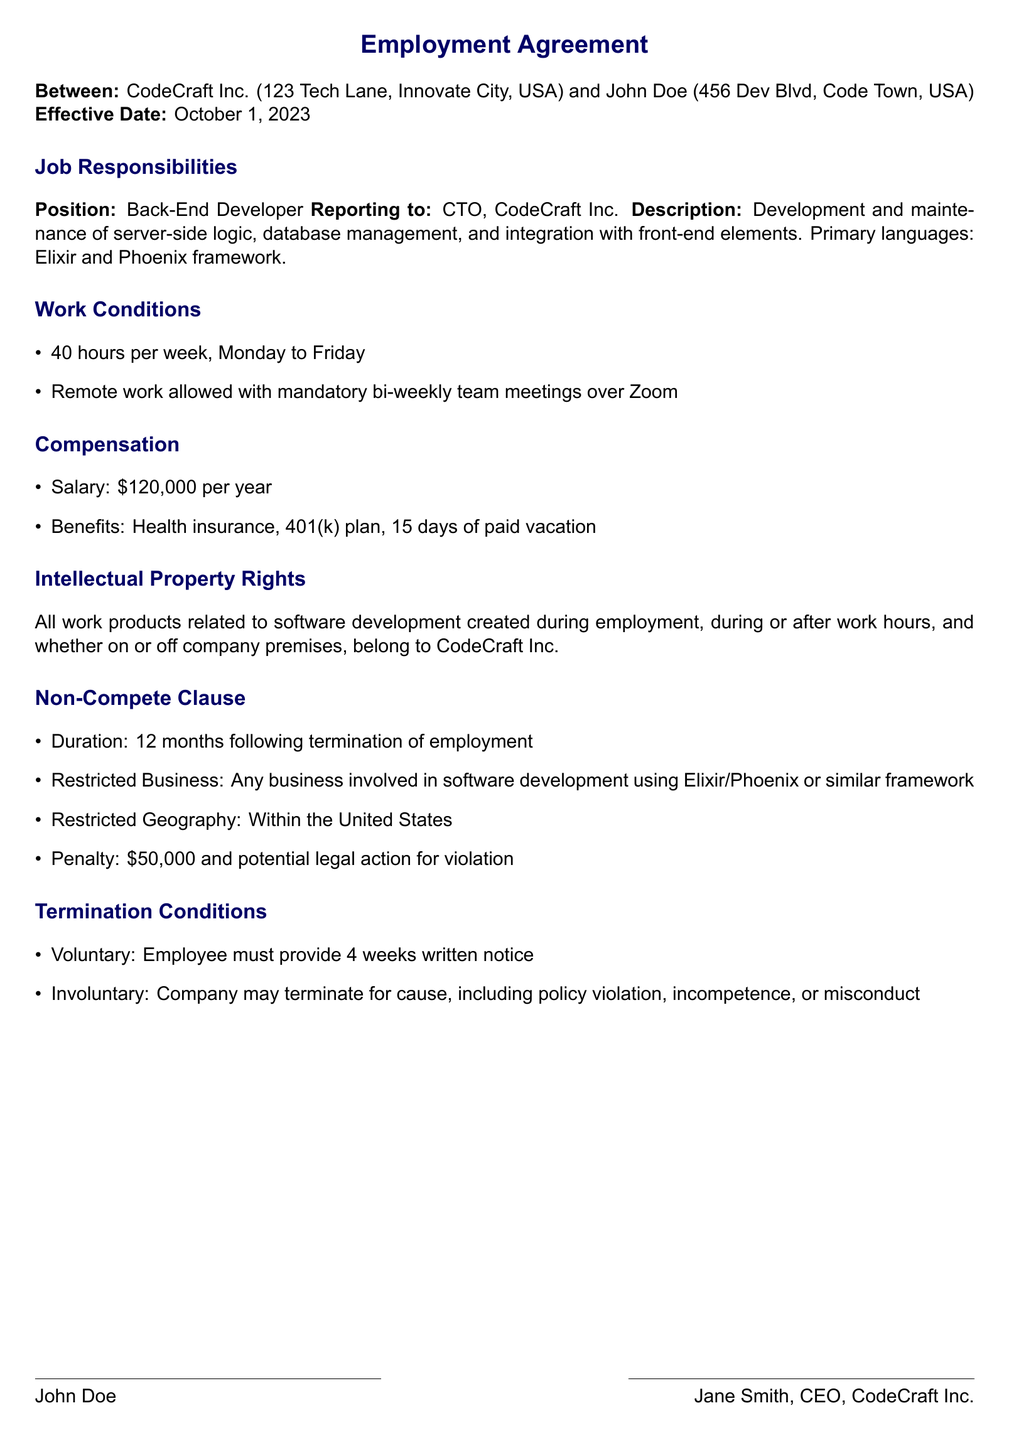What is the effective date of the employment agreement? The effective date is specified in the "Effective Date" section of the document as October 1, 2023.
Answer: October 1, 2023 Who is the reporting manager for the back-end developer? The reporting manager mentioned in the "Job Responsibilities" section is the CTO of CodeCraft Inc.
Answer: CTO What is the salary for the back-end developer position? The salary is listed under the "Compensation" section as the annual amount for the position.
Answer: $120,000 What is the duration of the non-compete clause? The non-compete clause specifies the period after termination during which the employee cannot compete.
Answer: 12 months What is the penalty for violating the non-compete clause? The document states the financial consequence for breach of the non-compete agreement.
Answer: $50,000 What type of work products belong to CodeCraft Inc.? The document under "Intellectual Property Rights" specifies the ownership of all work products related to software development.
Answer: All work products What is the notice period required for voluntary termination? The "Termination Conditions" section describes the written notice requirements for voluntary termination.
Answer: 4 weeks Under what circumstances can the company terminate the employment? The "Involuntary" termination conditions outline the reasons for termination by the employer.
Answer: For cause What benefits are included in the compensation package? The "Compensation" section lists the employee benefits provided, which includes health and retirement plans.
Answer: Health insurance, 401(k) plan, 15 days of paid vacation 